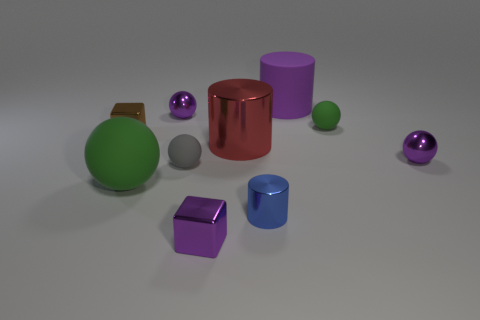Subtract all gray balls. How many balls are left? 4 Subtract all large spheres. How many spheres are left? 4 Subtract all red balls. Subtract all brown blocks. How many balls are left? 5 Subtract all blocks. How many objects are left? 8 Subtract all tiny things. Subtract all metal balls. How many objects are left? 1 Add 6 large green things. How many large green things are left? 7 Add 3 small blue cylinders. How many small blue cylinders exist? 4 Subtract 1 brown blocks. How many objects are left? 9 